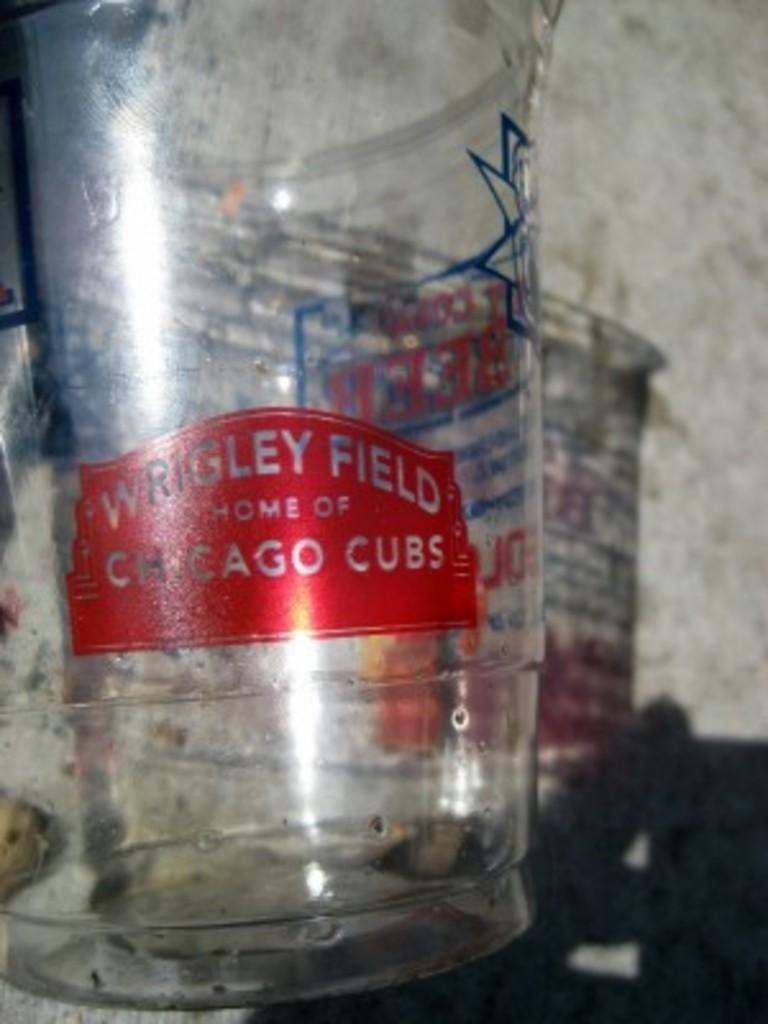Provide a one-sentence caption for the provided image. A plastic up that came from Wrigley Field in Chicago. 